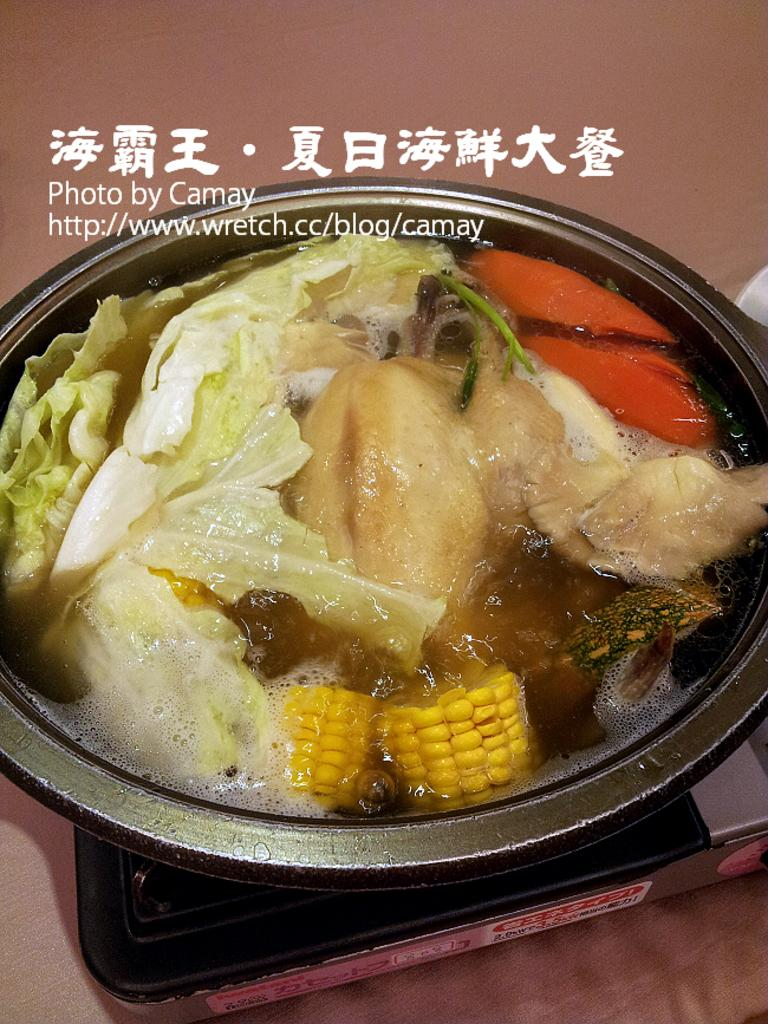What is inside the container that is visible in the image? There are food items in a container in the image. What is the container placed on? The container is placed on an object. What can be seen below the container in the image? The ground is visible in the image. What is written or displayed in the image? There is text present in the image. Where is the dad in the image? There is no dad present in the image. Can you describe the person wearing a coat in the image? There is no person wearing a coat in the image. 